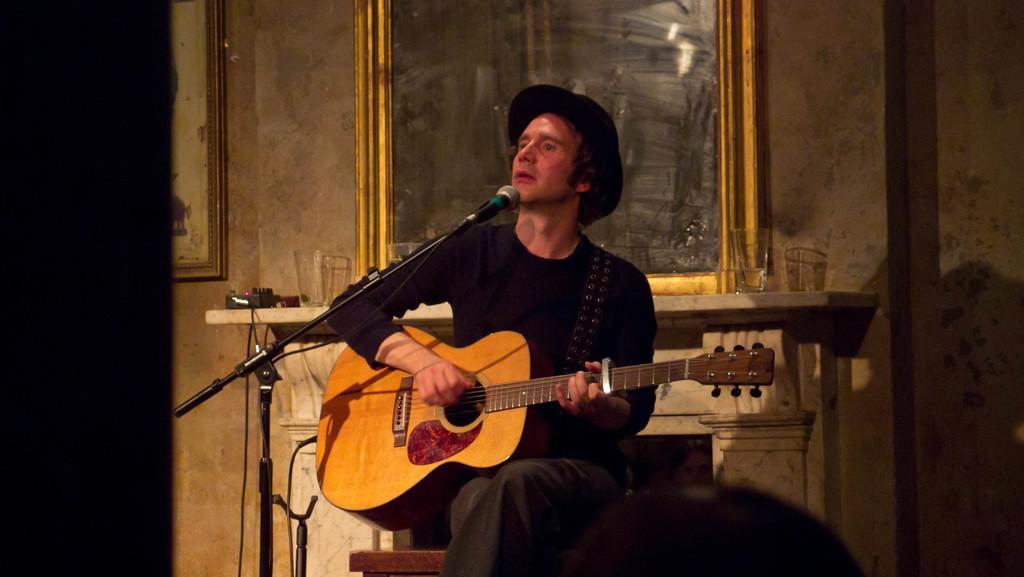What is the person in the image doing? The person is sitting on a chair and playing a guitar. What is the person positioned in front of? The person is in front of a microphone. What is the person wearing? The person is wearing a black t-shirt and a hat. What objects can be seen on the table? There are glasses on the table. What can be seen on the wall? There is a mirror and a picture on the wall. What type of brass instrument is the person playing in the image? The person is not playing a brass instrument in the image; they are playing a guitar. What type of lace is draped over the microphone in the image? There is no lace present in the image; the person is simply in front of a microphone. 